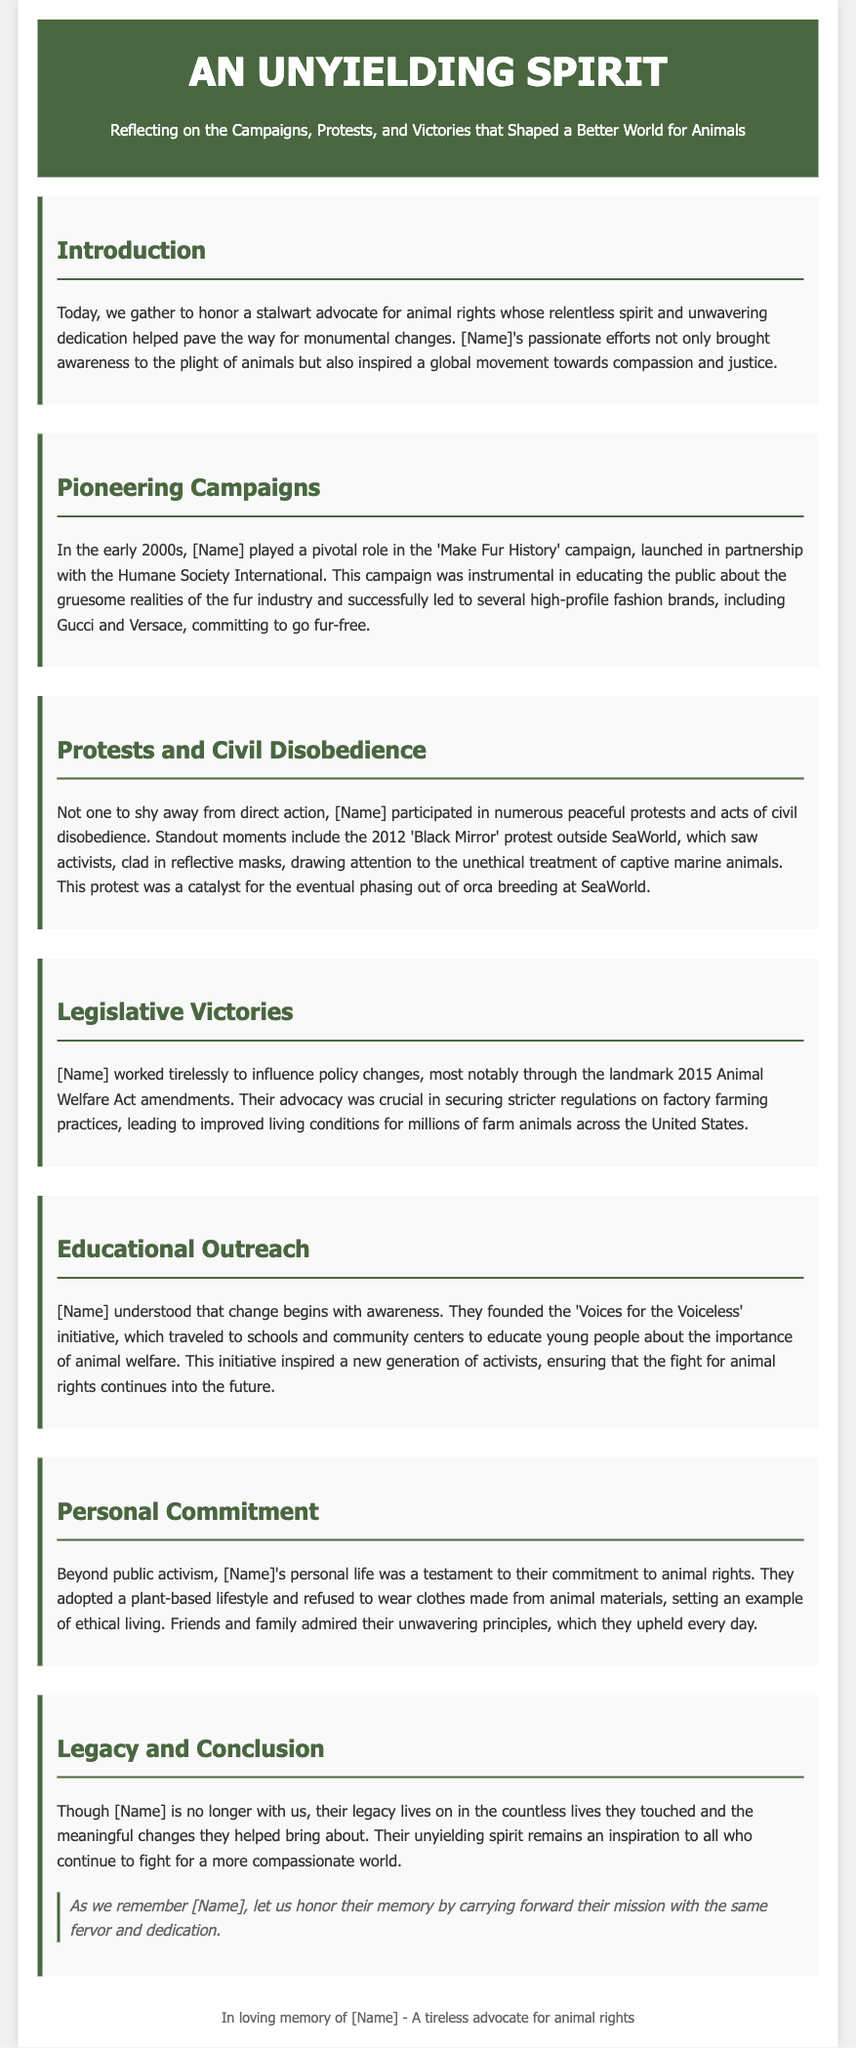what was the title of the campaign [Name] played a role in? The document mentions that [Name] played a pivotal role in the 'Make Fur History' campaign.
Answer: Make Fur History when did the 'Black Mirror' protest occur? The document states that the 'Black Mirror' protest took place in 2012.
Answer: 2012 what initiative did [Name] found for educational outreach? The document references that [Name] founded the 'Voices for the Voiceless' initiative.
Answer: Voices for the Voiceless what landmark legislation did [Name] influence in 2015? The document indicates that [Name] worked on the amendments to the Animal Welfare Act.
Answer: Animal Welfare Act what was [Name]'s lifestyle choice mentioned in the document? The document highlights that [Name] adopted a plant-based lifestyle.
Answer: plant-based lifestyle how did [Name] influence the fashion industry? The document states that [Name]'s campaign led several fashion brands to commit to going fur-free.
Answer: committed to go fur-free what was one outcome of the 'Black Mirror' protest? The document notes that it was a catalyst for the phasing out of orca breeding at SeaWorld.
Answer: phasing out of orca breeding how did [Name]'s personal life reflect their advocacy? The document mentions that [Name] refused to wear clothes made from animal materials.
Answer: refused to wear clothes made from animal materials what does the document suggest as a way to honor [Name]'s legacy? The document encourages carrying forward their mission with the same fervor and dedication.
Answer: carry forward their mission 